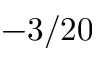Convert formula to latex. <formula><loc_0><loc_0><loc_500><loc_500>- 3 / 2 0</formula> 